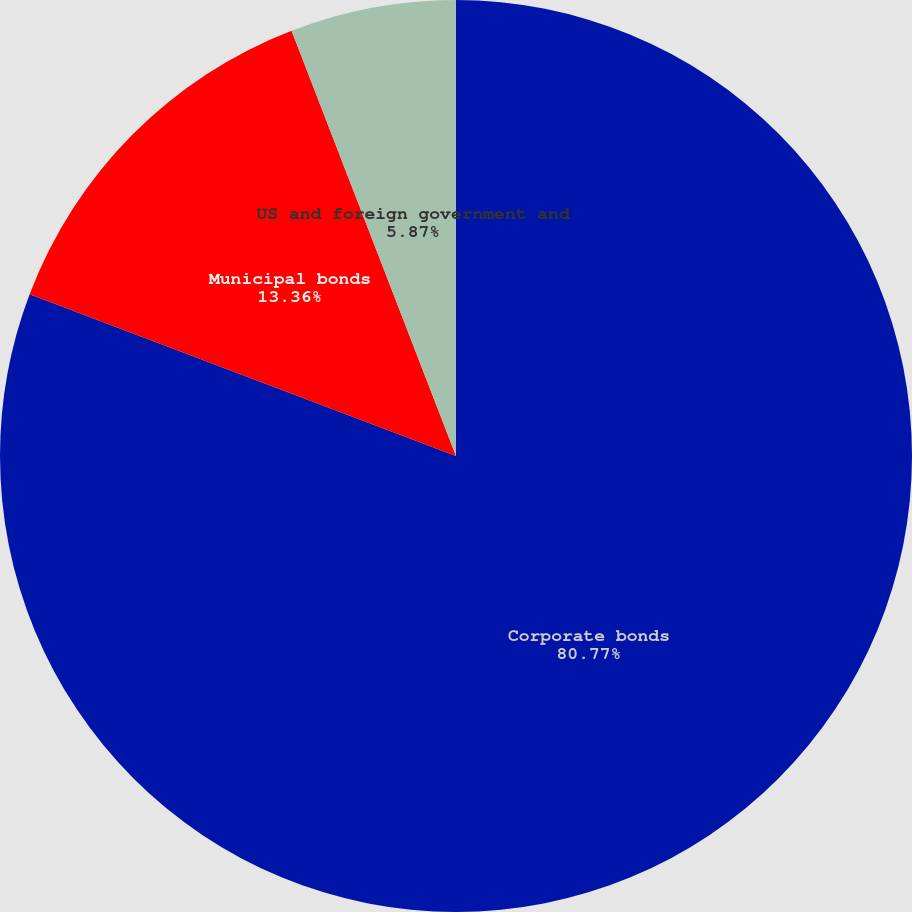<chart> <loc_0><loc_0><loc_500><loc_500><pie_chart><fcel>Corporate bonds<fcel>Municipal bonds<fcel>US and foreign government and<nl><fcel>80.76%<fcel>13.36%<fcel>5.87%<nl></chart> 